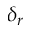<formula> <loc_0><loc_0><loc_500><loc_500>\delta _ { r }</formula> 